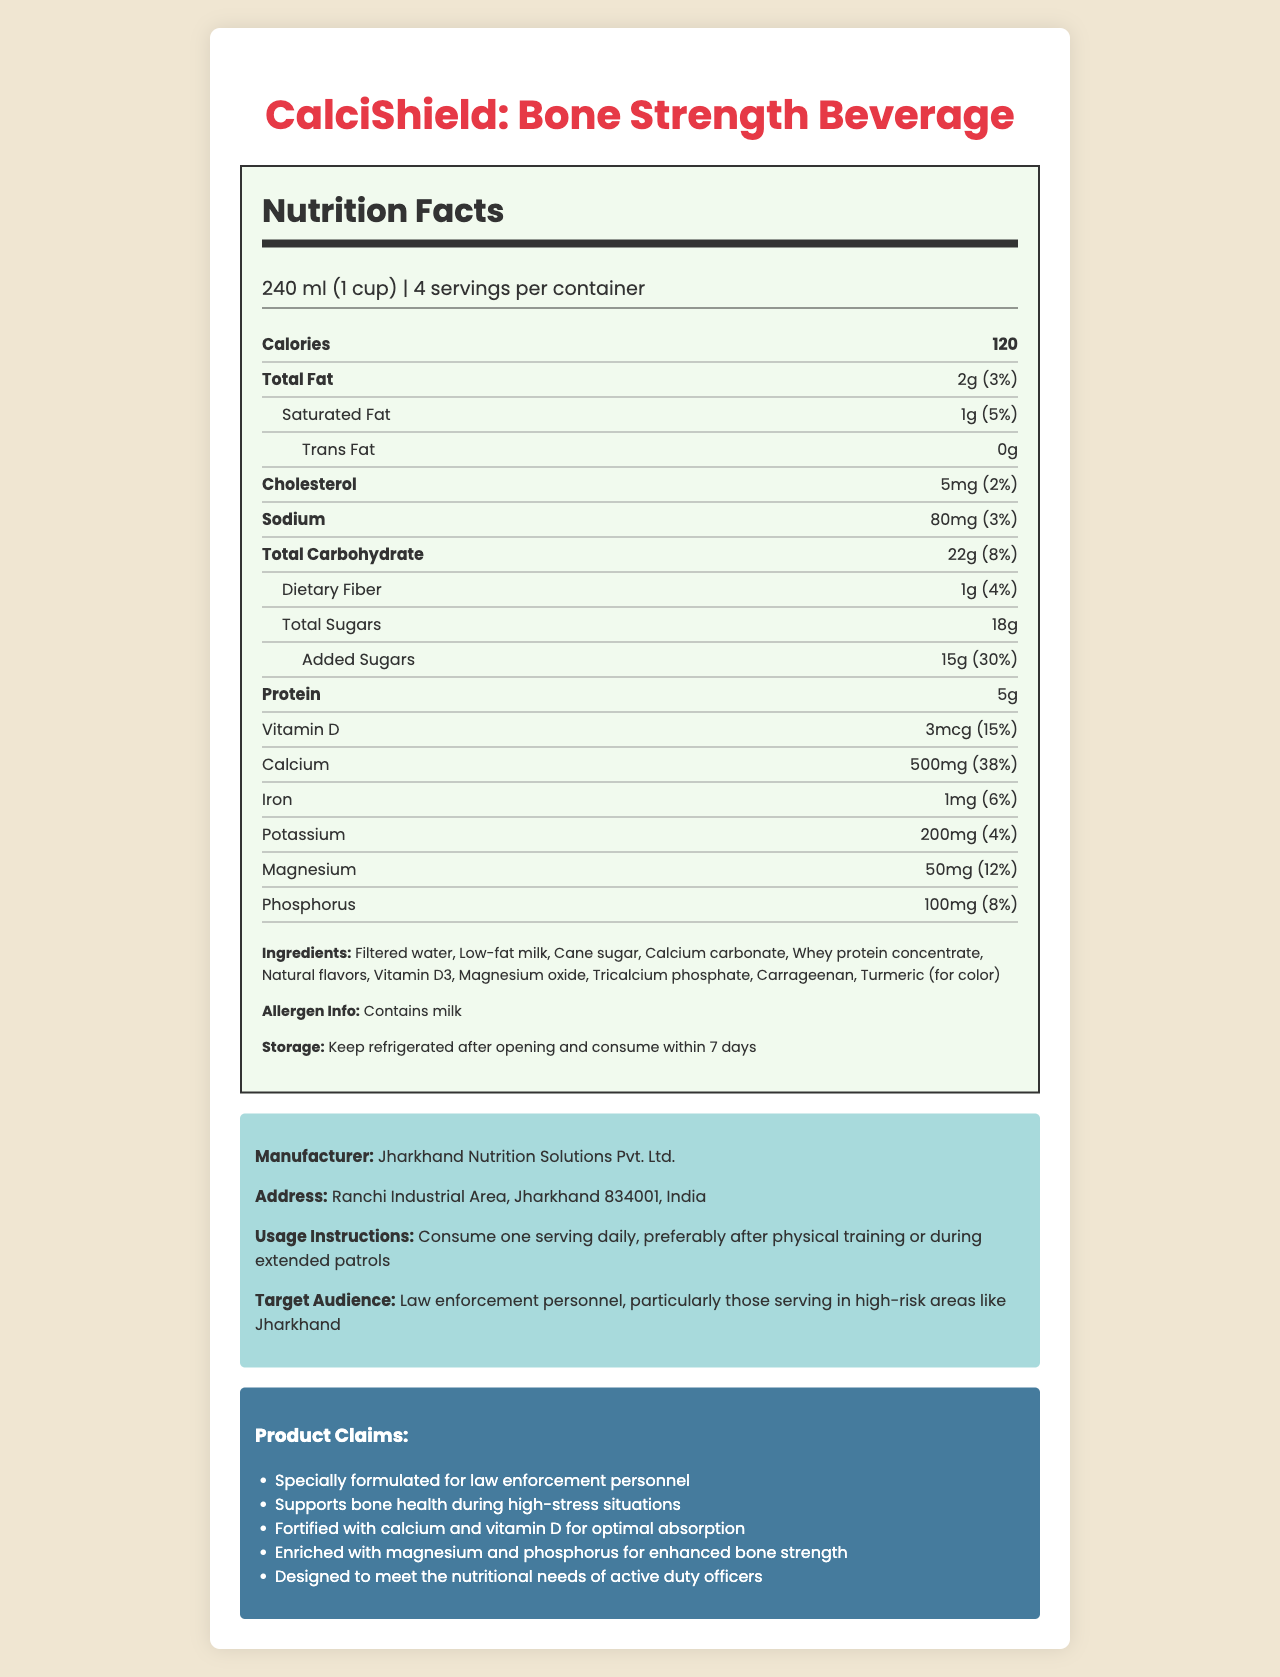who is the target audience for CalciShield: Bone Strength Beverage? The document states that the target audience is "Law enforcement personnel, particularly those serving in high-risk areas like Jharkhand."
Answer: Law enforcement personnel, particularly those serving in high-risk areas like Jharkhand how many servings does a container of CalciShield have? The document states that there are 4 servings per container.
Answer: 4 what is the serving size of CalciShield? The serving size is mentioned as "240 ml (1 cup)" in the document.
Answer: 240 ml (1 cup) how many grams of total fat are in one serving? The document lists the total fat per serving as "2g."
Answer: 2g how much calcium is in one serving, and what percentage of the daily value does it provide? According to the document, one serving contains 500mg of calcium, which is 38% of the daily value.
Answer: 500mg, 38% which vitamins and minerals are present in CalciShield? Select all that apply: A. Vitamin A B. Vitamin D C. Calcium D. Iron E. Potassium The document lists the presence of Vitamin D (3mcg), Calcium (500mg), Iron (1mg), and Potassium (200mg).
Answer: B, C, D, E how many grams of protein does one serving of CalciShield provide? The document states that each serving provides 5g of protein.
Answer: 5g what is the percentage daily value of added sugars in CalciShield? The document mentions that the added sugars in one serving account for 30% of the daily value.
Answer: 30% what is the storage instruction for CalciShield after opening? The document instructs to "Keep refrigerated after opening and consume within 7 days."
Answer: Keep refrigerated after opening and consume within 7 days does CalciShield contain any allergens? According to the document, "Contains milk."
Answer: Yes, it contains milk. what is the main focus of CalciShield's nutritional claims? The product claims mention that it "Supports bone health during high-stress situations."
Answer: Supports bone health during high-stress situations is CalciShield designed specifically for the general public? The target audience is law enforcement personnel, not the general public.
Answer: No describe the entire document or the main idea. The document comprehensively covers the nutritional details, usage, storage instructions, target audience, and claims of CalciShield: Bone Strength Beverage. It is designed for law enforcement personnel to support their bone health.
Answer: CalciShield: Bone Strength Beverage is a nutritional drink formulated for law enforcement personnel, especially those in high-risk areas like Jharkhand. It has multiple servings, detailed nutrition facts including vitamins and minerals, and specific usage and storage instructions. The product emphasizes support for bone health with calcium, vitamin D, magnesium, and phosphorus. how much saturated fat does CalciShield contain per serving? The document lists saturated fat content as "1g."
Answer: 1g how many grams of dietary fiber does each serving have? Dietary fiber content per serving is mentioned as "1g."
Answer: 1g which company manufactures CalciShield, and where is it located? The manufacturer listed is Jharkhand Nutrition Solutions Pvt. Ltd., located at Ranchi Industrial Area, Jharkhand 834001, India.
Answer: Jharkhand Nutrition Solutions Pvt. Ltd., Ranchi Industrial Area, Jharkhand 834001, India what is the total calorie count per serving? The document mentions that there are 120 calories per serving.
Answer: 120 calories what are the main ingredients of CalciShield? Select the correct combination: A. Filtered water, Cane sugar, Natural flavors B. Low-fat milk, Calcium carbonate, Vitamin D3 C. All of the above The document lists all these ingredients as part of the main ingredients of CalciShield.
Answer: C does the document provide information on side effects or health warnings? The document does not mention any side effects or health warnings.
Answer: Not enough information how much total carbohydrate and dietary fiber are in each serving? The document states that each serving contains 22g of total carbohydrates and 1g of dietary fiber.
Answer: Total Carbohydrate: 22g, Dietary Fiber: 1g 